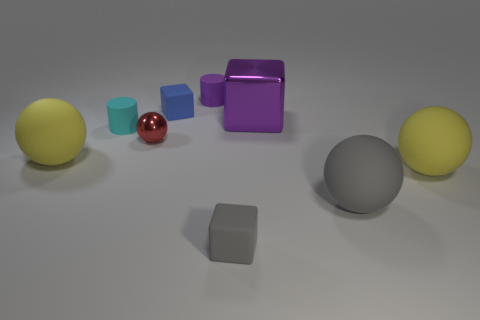Add 1 large purple balls. How many objects exist? 10 Subtract all cyan cylinders. How many yellow spheres are left? 2 Subtract all tiny blue rubber cubes. How many cubes are left? 2 Subtract 1 spheres. How many spheres are left? 3 Subtract all red balls. How many balls are left? 3 Subtract all cylinders. How many objects are left? 7 Subtract 1 purple cylinders. How many objects are left? 8 Subtract all purple balls. Subtract all red cylinders. How many balls are left? 4 Subtract all yellow spheres. Subtract all small blue blocks. How many objects are left? 6 Add 7 small blue matte objects. How many small blue matte objects are left? 8 